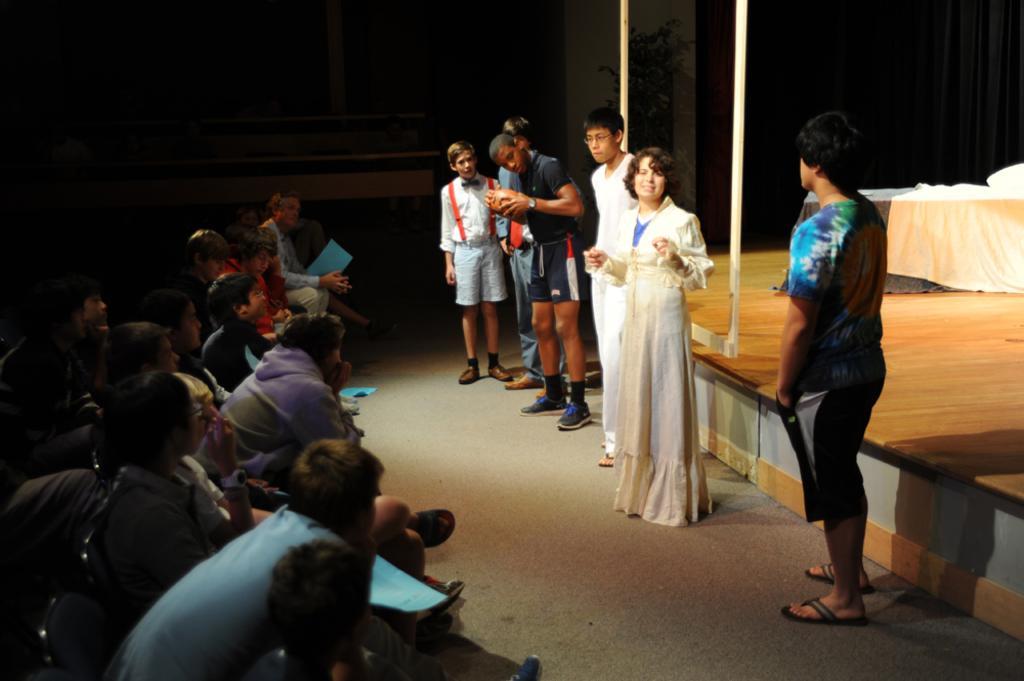Describe this image in one or two sentences. People are seated on the left. Few people are standing. There is a stage on the right which has a frame and a table. There is a plant at the back. 